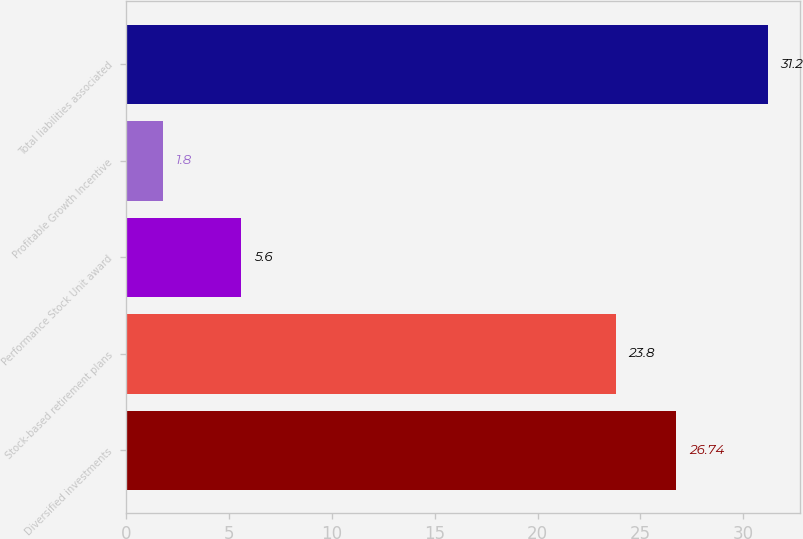<chart> <loc_0><loc_0><loc_500><loc_500><bar_chart><fcel>Diversified investments<fcel>Stock-based retirement plans<fcel>Performance Stock Unit award<fcel>Profitable Growth Incentive<fcel>Total liabilities associated<nl><fcel>26.74<fcel>23.8<fcel>5.6<fcel>1.8<fcel>31.2<nl></chart> 